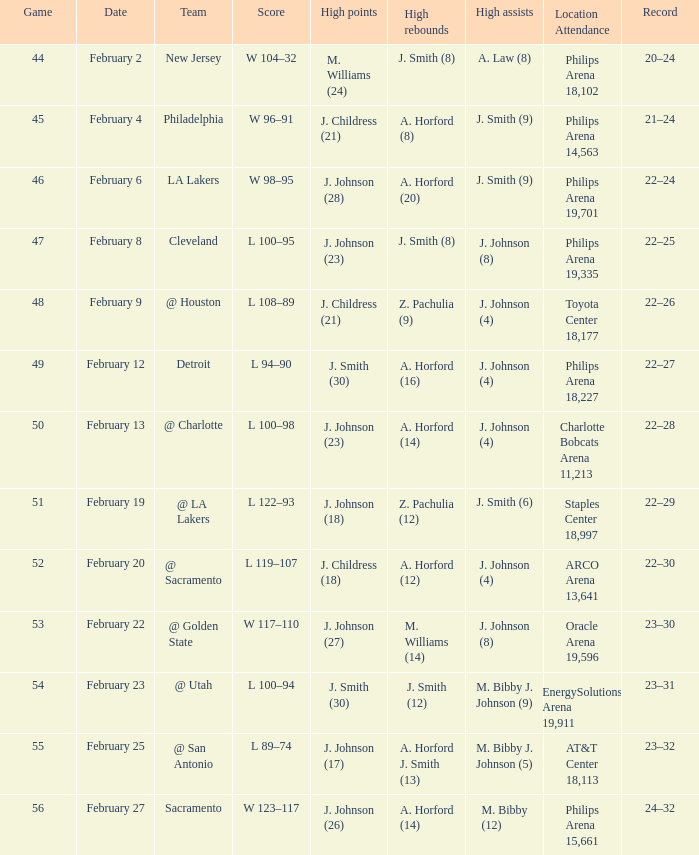Which team can be found at the philips arena, which has a capacity of 18,227 seats? Detroit. 